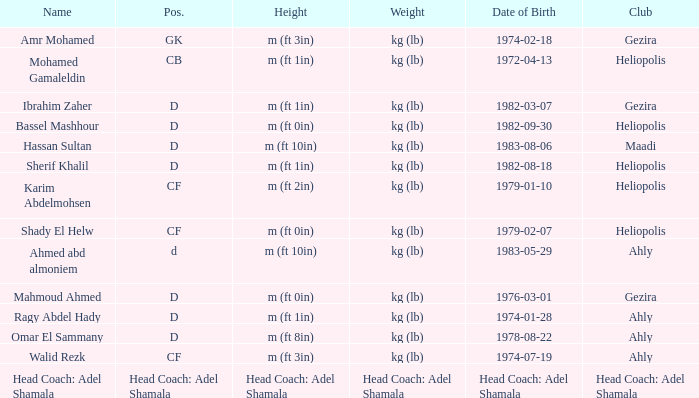When the club is maadi, what is the meaning of weight? Kg (lb). 